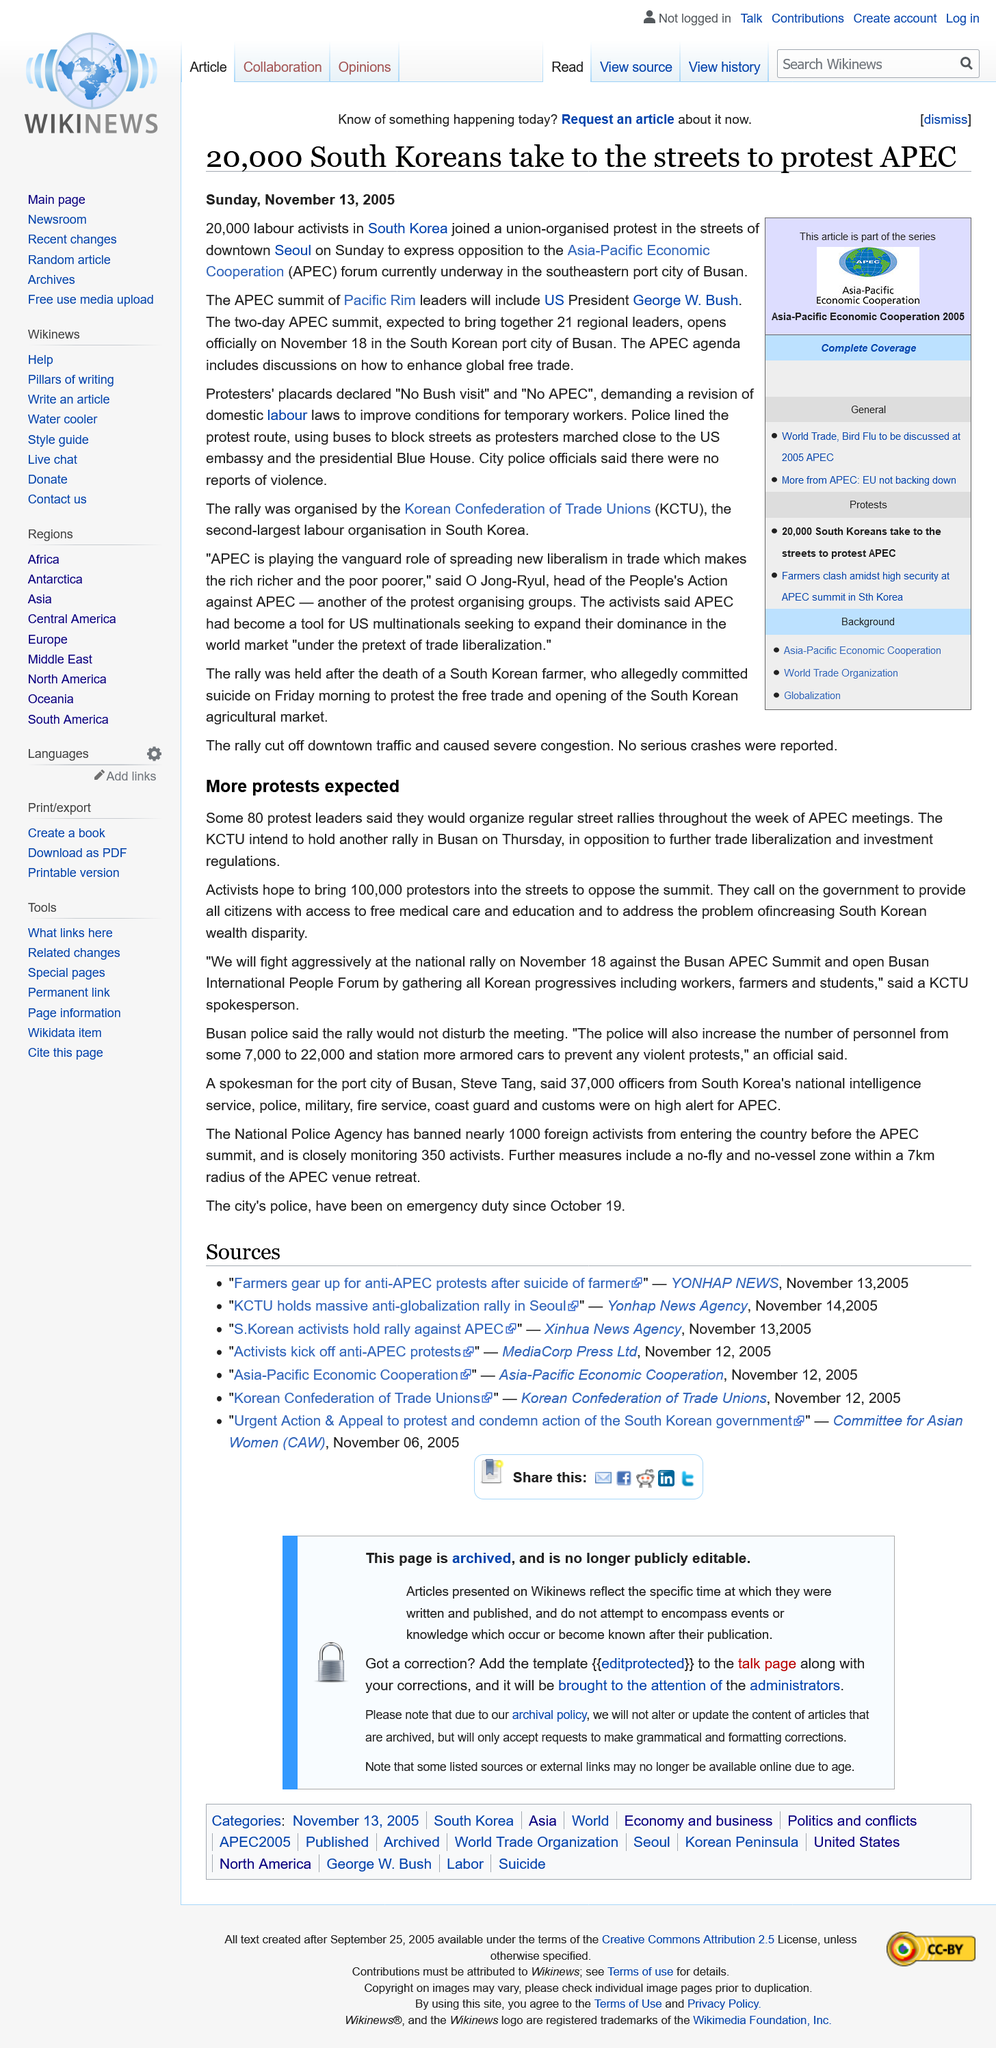Draw attention to some important aspects in this diagram. The placards held by the protesters declared with certainty that they were against the visit of President Bush and the APEC summit, and they also called for a revision of domestic labor laws. More than twenty thousand South Korean labor activists took to the streets to protest the Asia-Pacific Economic Cooperation (APEC) summit, reflecting widespread dissatisfaction with the event and the government's handling of it. The APEC agenda includes discussions on enhancing global free trade, which is a critical component of promoting economic growth and prosperity. 